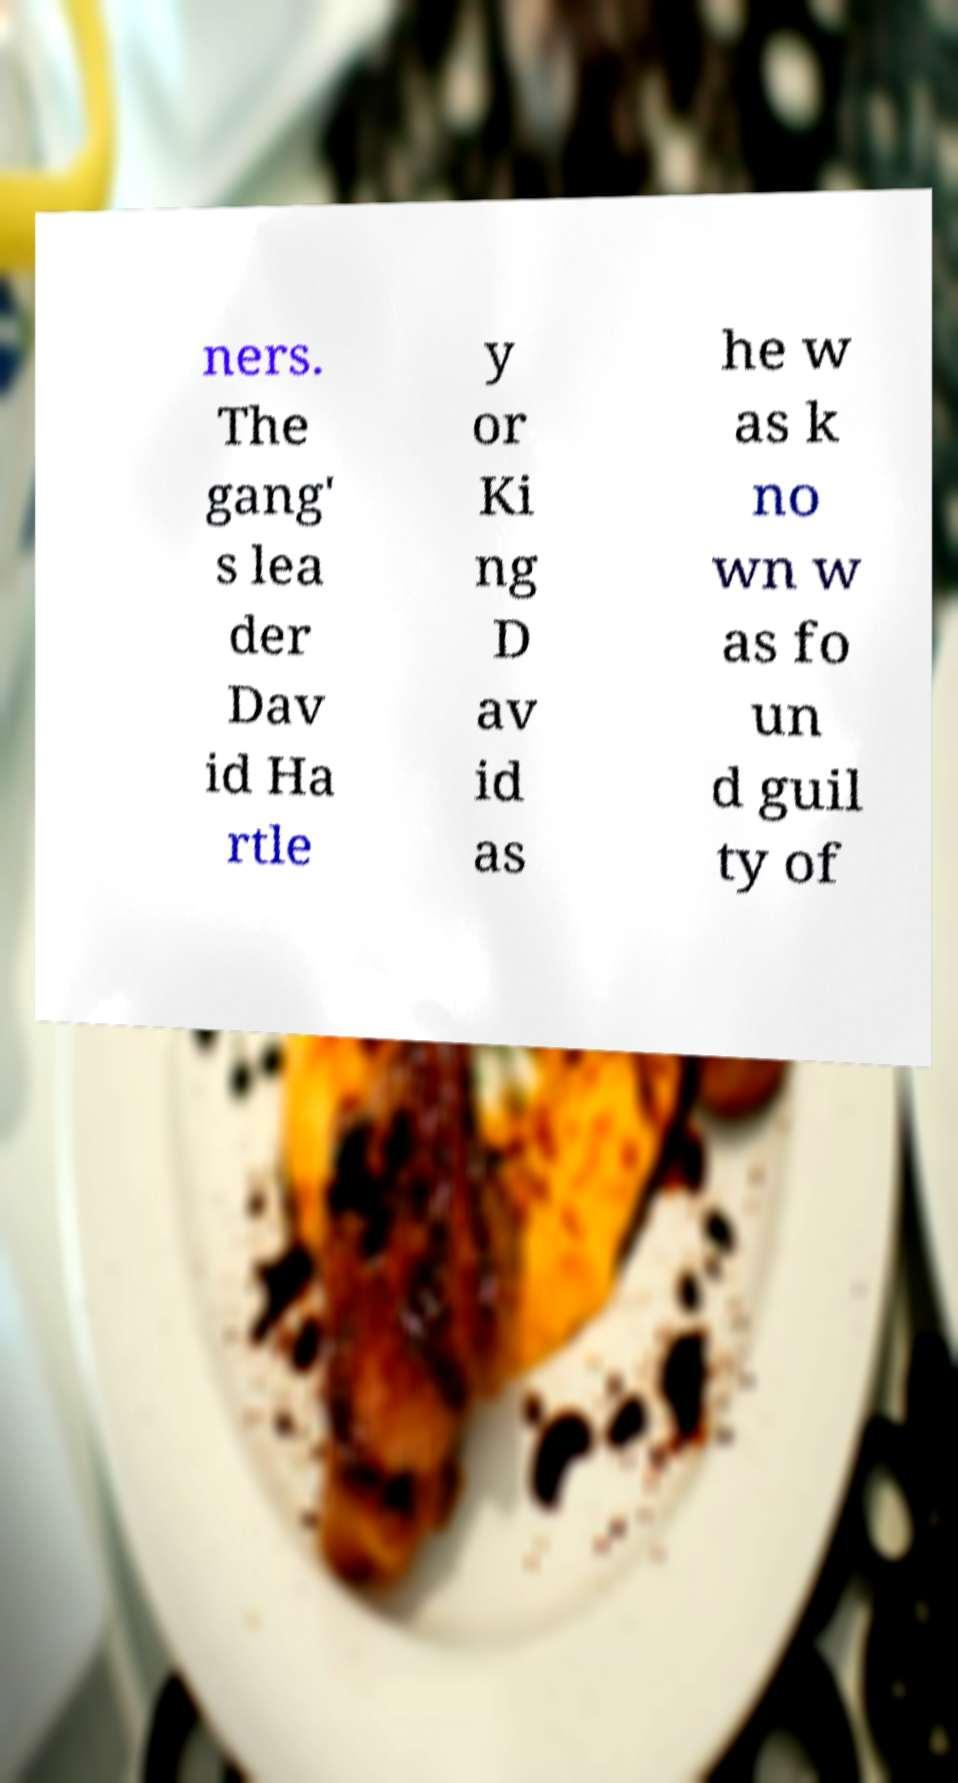Could you extract and type out the text from this image? ners. The gang' s lea der Dav id Ha rtle y or Ki ng D av id as he w as k no wn w as fo un d guil ty of 